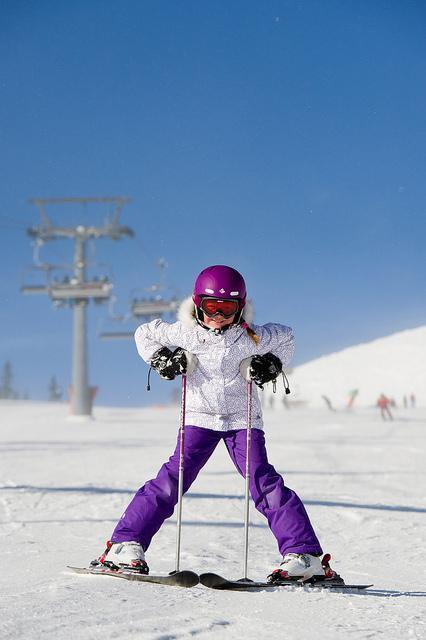How many people are visible?
Give a very brief answer. 1. How many choices of food do the sheep have?
Give a very brief answer. 0. 